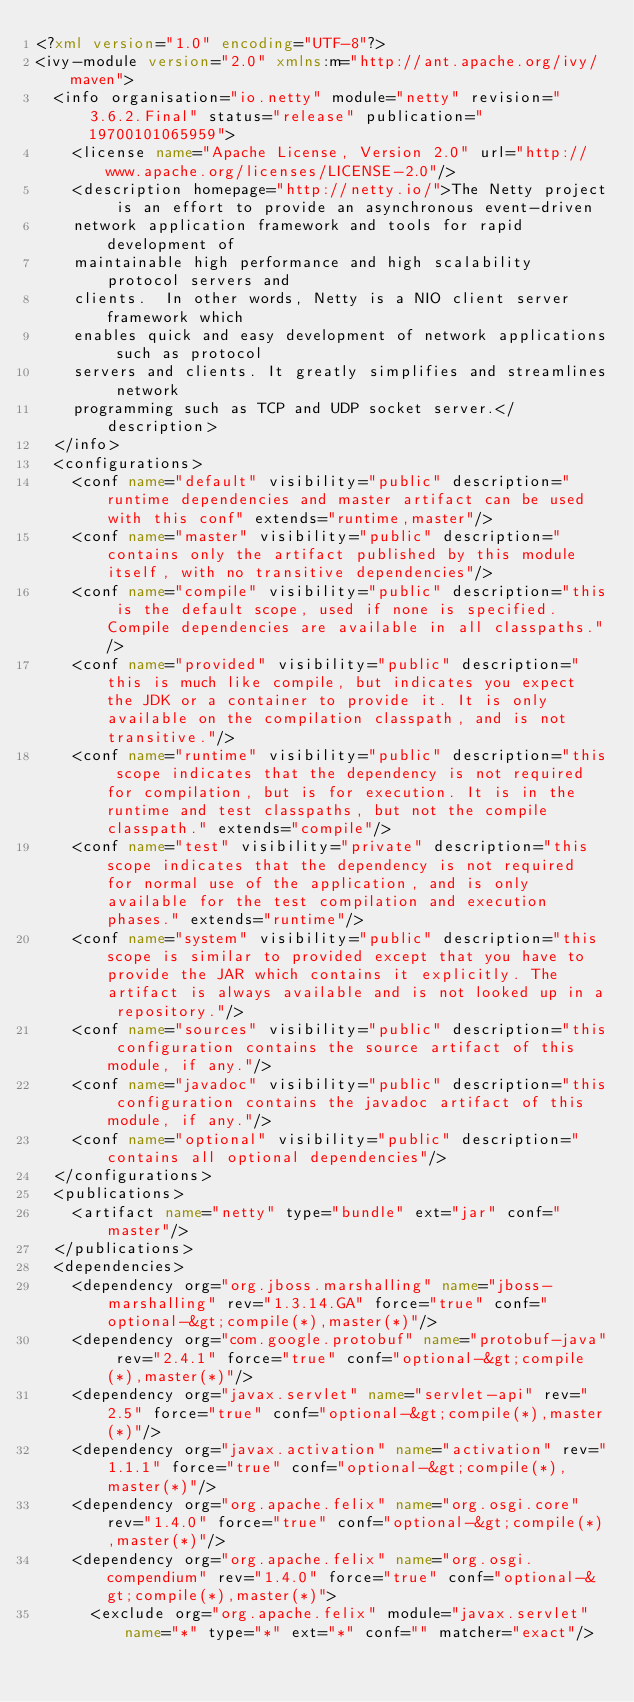Convert code to text. <code><loc_0><loc_0><loc_500><loc_500><_XML_><?xml version="1.0" encoding="UTF-8"?>
<ivy-module version="2.0" xmlns:m="http://ant.apache.org/ivy/maven">
  <info organisation="io.netty" module="netty" revision="3.6.2.Final" status="release" publication="19700101065959">
    <license name="Apache License, Version 2.0" url="http://www.apache.org/licenses/LICENSE-2.0"/>
    <description homepage="http://netty.io/">The Netty project is an effort to provide an asynchronous event-driven
    network application framework and tools for rapid development of
    maintainable high performance and high scalability protocol servers and
    clients.  In other words, Netty is a NIO client server framework which
    enables quick and easy development of network applications such as protocol
    servers and clients. It greatly simplifies and streamlines network
    programming such as TCP and UDP socket server.</description>
  </info>
  <configurations>
    <conf name="default" visibility="public" description="runtime dependencies and master artifact can be used with this conf" extends="runtime,master"/>
    <conf name="master" visibility="public" description="contains only the artifact published by this module itself, with no transitive dependencies"/>
    <conf name="compile" visibility="public" description="this is the default scope, used if none is specified. Compile dependencies are available in all classpaths."/>
    <conf name="provided" visibility="public" description="this is much like compile, but indicates you expect the JDK or a container to provide it. It is only available on the compilation classpath, and is not transitive."/>
    <conf name="runtime" visibility="public" description="this scope indicates that the dependency is not required for compilation, but is for execution. It is in the runtime and test classpaths, but not the compile classpath." extends="compile"/>
    <conf name="test" visibility="private" description="this scope indicates that the dependency is not required for normal use of the application, and is only available for the test compilation and execution phases." extends="runtime"/>
    <conf name="system" visibility="public" description="this scope is similar to provided except that you have to provide the JAR which contains it explicitly. The artifact is always available and is not looked up in a repository."/>
    <conf name="sources" visibility="public" description="this configuration contains the source artifact of this module, if any."/>
    <conf name="javadoc" visibility="public" description="this configuration contains the javadoc artifact of this module, if any."/>
    <conf name="optional" visibility="public" description="contains all optional dependencies"/>
  </configurations>
  <publications>
    <artifact name="netty" type="bundle" ext="jar" conf="master"/>
  </publications>
  <dependencies>
    <dependency org="org.jboss.marshalling" name="jboss-marshalling" rev="1.3.14.GA" force="true" conf="optional-&gt;compile(*),master(*)"/>
    <dependency org="com.google.protobuf" name="protobuf-java" rev="2.4.1" force="true" conf="optional-&gt;compile(*),master(*)"/>
    <dependency org="javax.servlet" name="servlet-api" rev="2.5" force="true" conf="optional-&gt;compile(*),master(*)"/>
    <dependency org="javax.activation" name="activation" rev="1.1.1" force="true" conf="optional-&gt;compile(*),master(*)"/>
    <dependency org="org.apache.felix" name="org.osgi.core" rev="1.4.0" force="true" conf="optional-&gt;compile(*),master(*)"/>
    <dependency org="org.apache.felix" name="org.osgi.compendium" rev="1.4.0" force="true" conf="optional-&gt;compile(*),master(*)">
      <exclude org="org.apache.felix" module="javax.servlet" name="*" type="*" ext="*" conf="" matcher="exact"/></code> 